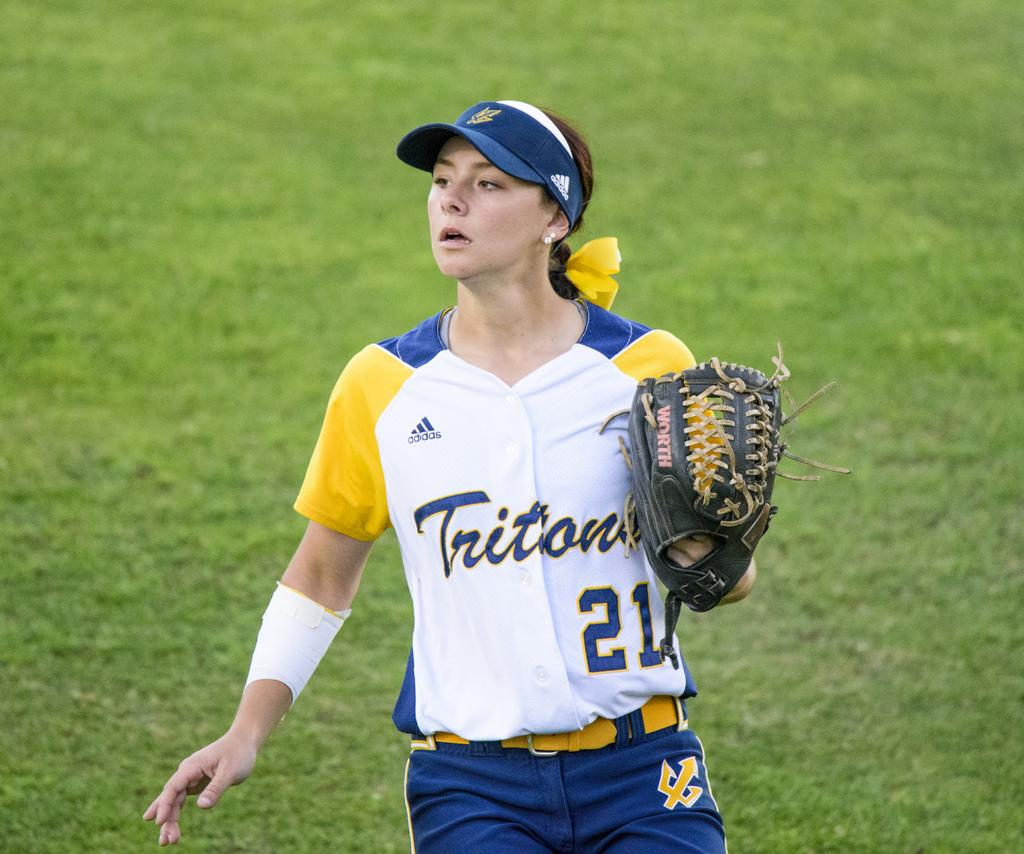<image>
Create a compact narrative representing the image presented. a woman in a Titons number 21 jersey holds a baseball mitt mid game 